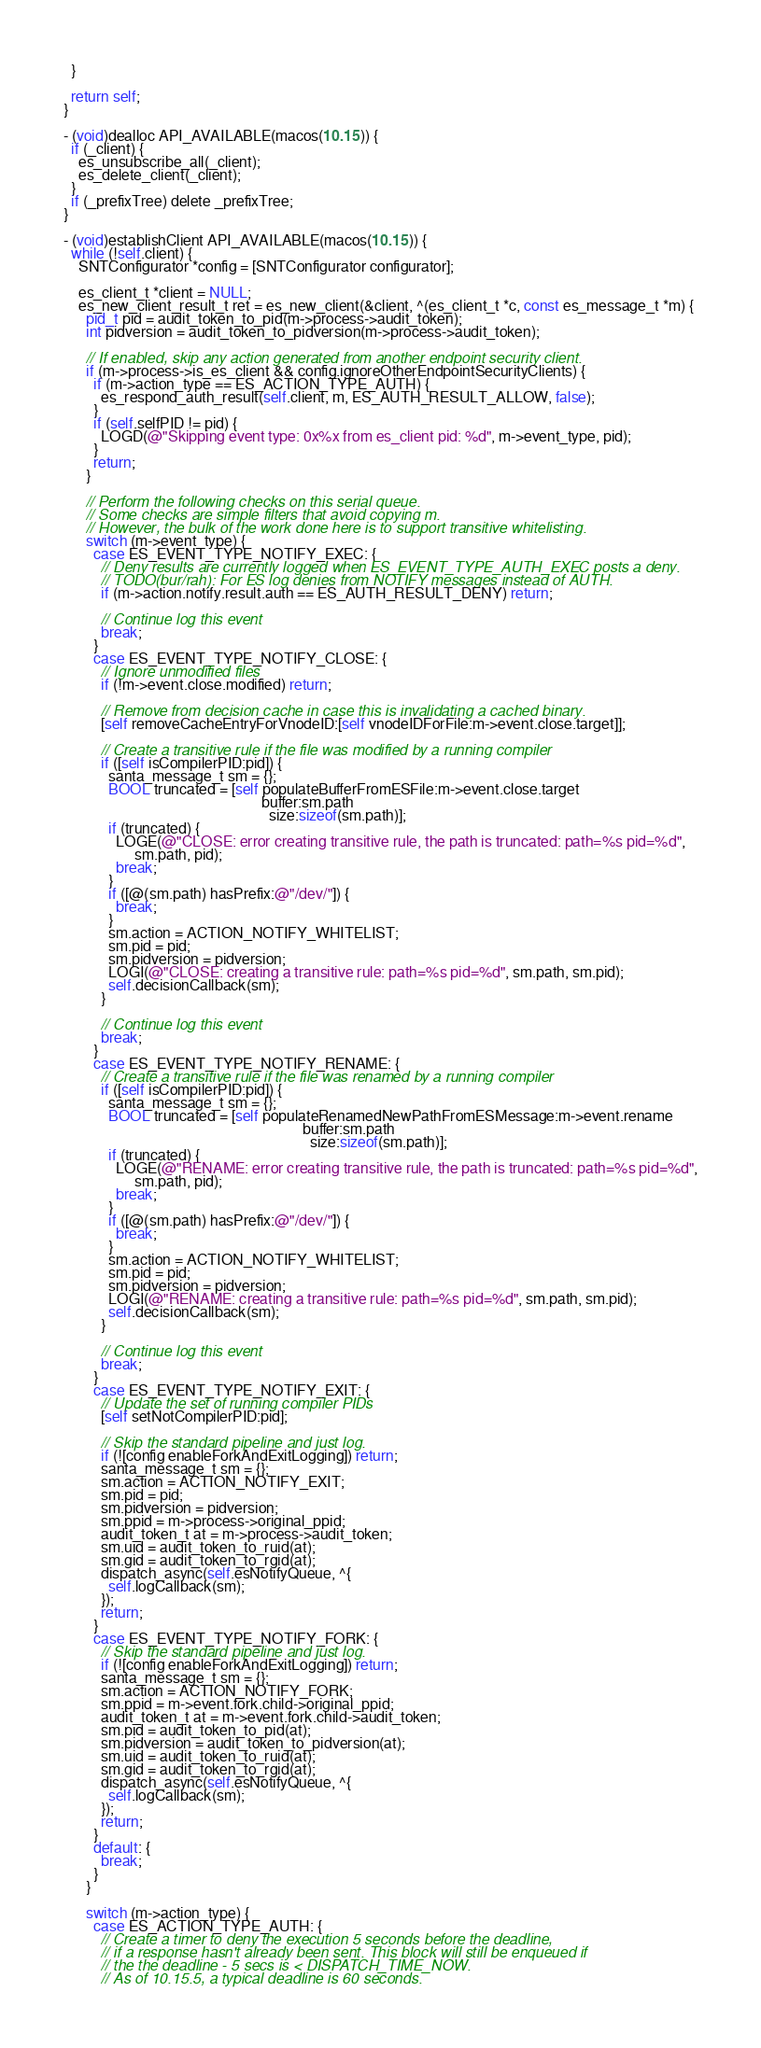Convert code to text. <code><loc_0><loc_0><loc_500><loc_500><_ObjectiveC_>  }

  return self;
}

- (void)dealloc API_AVAILABLE(macos(10.15)) {
  if (_client) {
    es_unsubscribe_all(_client);
    es_delete_client(_client);
  }
  if (_prefixTree) delete _prefixTree;
}

- (void)establishClient API_AVAILABLE(macos(10.15)) {
  while (!self.client) {
    SNTConfigurator *config = [SNTConfigurator configurator];

    es_client_t *client = NULL;
    es_new_client_result_t ret = es_new_client(&client, ^(es_client_t *c, const es_message_t *m) {
      pid_t pid = audit_token_to_pid(m->process->audit_token);
      int pidversion = audit_token_to_pidversion(m->process->audit_token);

      // If enabled, skip any action generated from another endpoint security client.
      if (m->process->is_es_client && config.ignoreOtherEndpointSecurityClients) {
        if (m->action_type == ES_ACTION_TYPE_AUTH) {
          es_respond_auth_result(self.client, m, ES_AUTH_RESULT_ALLOW, false);
        }
        if (self.selfPID != pid) {
          LOGD(@"Skipping event type: 0x%x from es_client pid: %d", m->event_type, pid);
        }
        return;
      }

      // Perform the following checks on this serial queue.
      // Some checks are simple filters that avoid copying m.
      // However, the bulk of the work done here is to support transitive whitelisting.
      switch (m->event_type) {
        case ES_EVENT_TYPE_NOTIFY_EXEC: {
          // Deny results are currently logged when ES_EVENT_TYPE_AUTH_EXEC posts a deny.
          // TODO(bur/rah): For ES log denies from NOTIFY messages instead of AUTH.
          if (m->action.notify.result.auth == ES_AUTH_RESULT_DENY) return;

          // Continue log this event
          break;
        }
        case ES_EVENT_TYPE_NOTIFY_CLOSE: {
          // Ignore unmodified files
          if (!m->event.close.modified) return;

          // Remove from decision cache in case this is invalidating a cached binary.
          [self removeCacheEntryForVnodeID:[self vnodeIDForFile:m->event.close.target]];

          // Create a transitive rule if the file was modified by a running compiler
          if ([self isCompilerPID:pid]) {
            santa_message_t sm = {};
            BOOL truncated = [self populateBufferFromESFile:m->event.close.target
                                                     buffer:sm.path
                                                       size:sizeof(sm.path)];
            if (truncated) {
              LOGE(@"CLOSE: error creating transitive rule, the path is truncated: path=%s pid=%d",
                   sm.path, pid);
              break;
            }
            if ([@(sm.path) hasPrefix:@"/dev/"]) {
              break;
            }
            sm.action = ACTION_NOTIFY_WHITELIST;
            sm.pid = pid;
            sm.pidversion = pidversion;
            LOGI(@"CLOSE: creating a transitive rule: path=%s pid=%d", sm.path, sm.pid);
            self.decisionCallback(sm);
          }

          // Continue log this event
          break;
        }
        case ES_EVENT_TYPE_NOTIFY_RENAME: {
          // Create a transitive rule if the file was renamed by a running compiler
          if ([self isCompilerPID:pid]) {
            santa_message_t sm = {};
            BOOL truncated = [self populateRenamedNewPathFromESMessage:m->event.rename
                                                                buffer:sm.path
                                                                  size:sizeof(sm.path)];
            if (truncated) {
              LOGE(@"RENAME: error creating transitive rule, the path is truncated: path=%s pid=%d",
                   sm.path, pid);
              break;
            }
            if ([@(sm.path) hasPrefix:@"/dev/"]) {
              break;
            }
            sm.action = ACTION_NOTIFY_WHITELIST;
            sm.pid = pid;
            sm.pidversion = pidversion;
            LOGI(@"RENAME: creating a transitive rule: path=%s pid=%d", sm.path, sm.pid);
            self.decisionCallback(sm);
          }

          // Continue log this event
          break;
        }
        case ES_EVENT_TYPE_NOTIFY_EXIT: {
          // Update the set of running compiler PIDs
          [self setNotCompilerPID:pid];

          // Skip the standard pipeline and just log.
          if (![config enableForkAndExitLogging]) return;
          santa_message_t sm = {};
          sm.action = ACTION_NOTIFY_EXIT;
          sm.pid = pid;
          sm.pidversion = pidversion;
          sm.ppid = m->process->original_ppid;
          audit_token_t at = m->process->audit_token;
          sm.uid = audit_token_to_ruid(at);
          sm.gid = audit_token_to_rgid(at);
          dispatch_async(self.esNotifyQueue, ^{
            self.logCallback(sm);
          });
          return;
        }
        case ES_EVENT_TYPE_NOTIFY_FORK: {
          // Skip the standard pipeline and just log.
          if (![config enableForkAndExitLogging]) return;
          santa_message_t sm = {};
          sm.action = ACTION_NOTIFY_FORK;
          sm.ppid = m->event.fork.child->original_ppid;
          audit_token_t at = m->event.fork.child->audit_token;
          sm.pid = audit_token_to_pid(at);
          sm.pidversion = audit_token_to_pidversion(at);
          sm.uid = audit_token_to_ruid(at);
          sm.gid = audit_token_to_rgid(at);
          dispatch_async(self.esNotifyQueue, ^{
            self.logCallback(sm);
          });
          return;
        }
        default: {
          break;
        }
      }

      switch (m->action_type) {
        case ES_ACTION_TYPE_AUTH: {
          // Create a timer to deny the execution 5 seconds before the deadline,
          // if a response hasn't already been sent. This block will still be enqueued if
          // the the deadline - 5 secs is < DISPATCH_TIME_NOW.
          // As of 10.15.5, a typical deadline is 60 seconds.</code> 